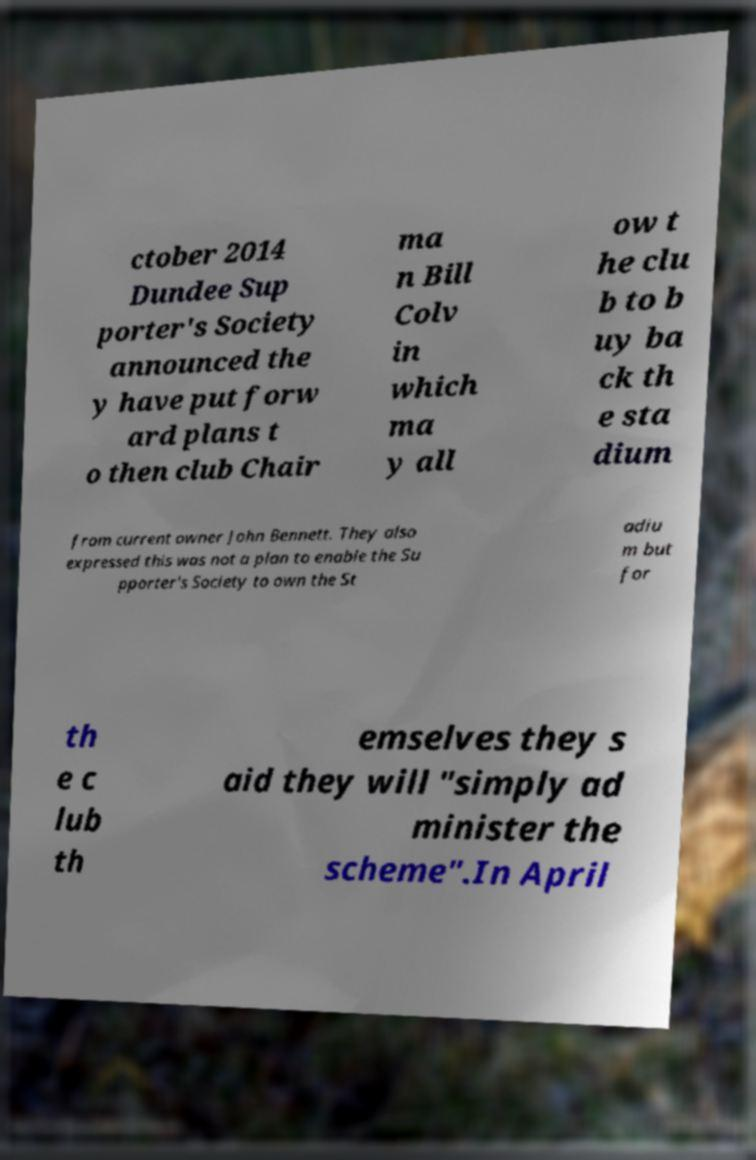Please read and relay the text visible in this image. What does it say? ctober 2014 Dundee Sup porter's Society announced the y have put forw ard plans t o then club Chair ma n Bill Colv in which ma y all ow t he clu b to b uy ba ck th e sta dium from current owner John Bennett. They also expressed this was not a plan to enable the Su pporter's Society to own the St adiu m but for th e c lub th emselves they s aid they will "simply ad minister the scheme".In April 